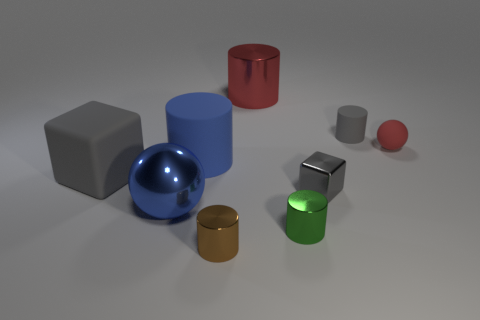How many spheres are either metal objects or small red things?
Your response must be concise. 2. What is the material of the green object that is the same shape as the brown shiny object?
Offer a very short reply. Metal. The gray cube that is the same material as the green cylinder is what size?
Keep it short and to the point. Small. There is a red thing in front of the big red metallic cylinder; is it the same shape as the gray rubber object that is left of the brown object?
Make the answer very short. No. There is a big object that is made of the same material as the red cylinder; what color is it?
Provide a short and direct response. Blue. There is a ball that is to the left of the matte ball; does it have the same size as the metal object behind the big rubber cylinder?
Give a very brief answer. Yes. What is the shape of the big thing that is on the right side of the large blue sphere and left of the small brown shiny thing?
Provide a succinct answer. Cylinder. Are there any tiny green objects that have the same material as the small cube?
Your answer should be compact. Yes. There is a ball that is the same color as the big metallic cylinder; what is it made of?
Ensure brevity in your answer.  Rubber. Is the material of the gray thing left of the small brown object the same as the tiny cylinder that is behind the blue matte cylinder?
Keep it short and to the point. Yes. 